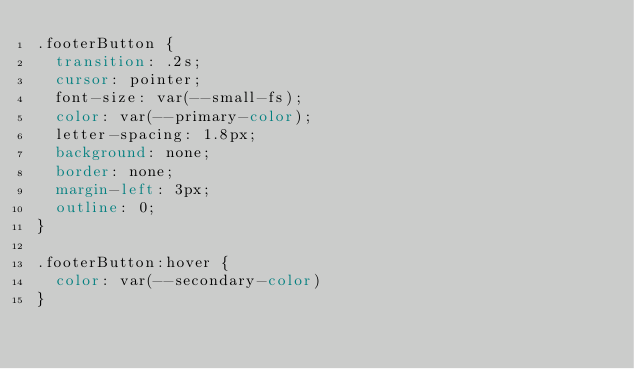<code> <loc_0><loc_0><loc_500><loc_500><_CSS_>.footerButton {
  transition: .2s;
  cursor: pointer;
  font-size: var(--small-fs);
  color: var(--primary-color);
  letter-spacing: 1.8px;
  background: none;
  border: none;
  margin-left: 3px;
  outline: 0;
}

.footerButton:hover {
  color: var(--secondary-color)
}
</code> 